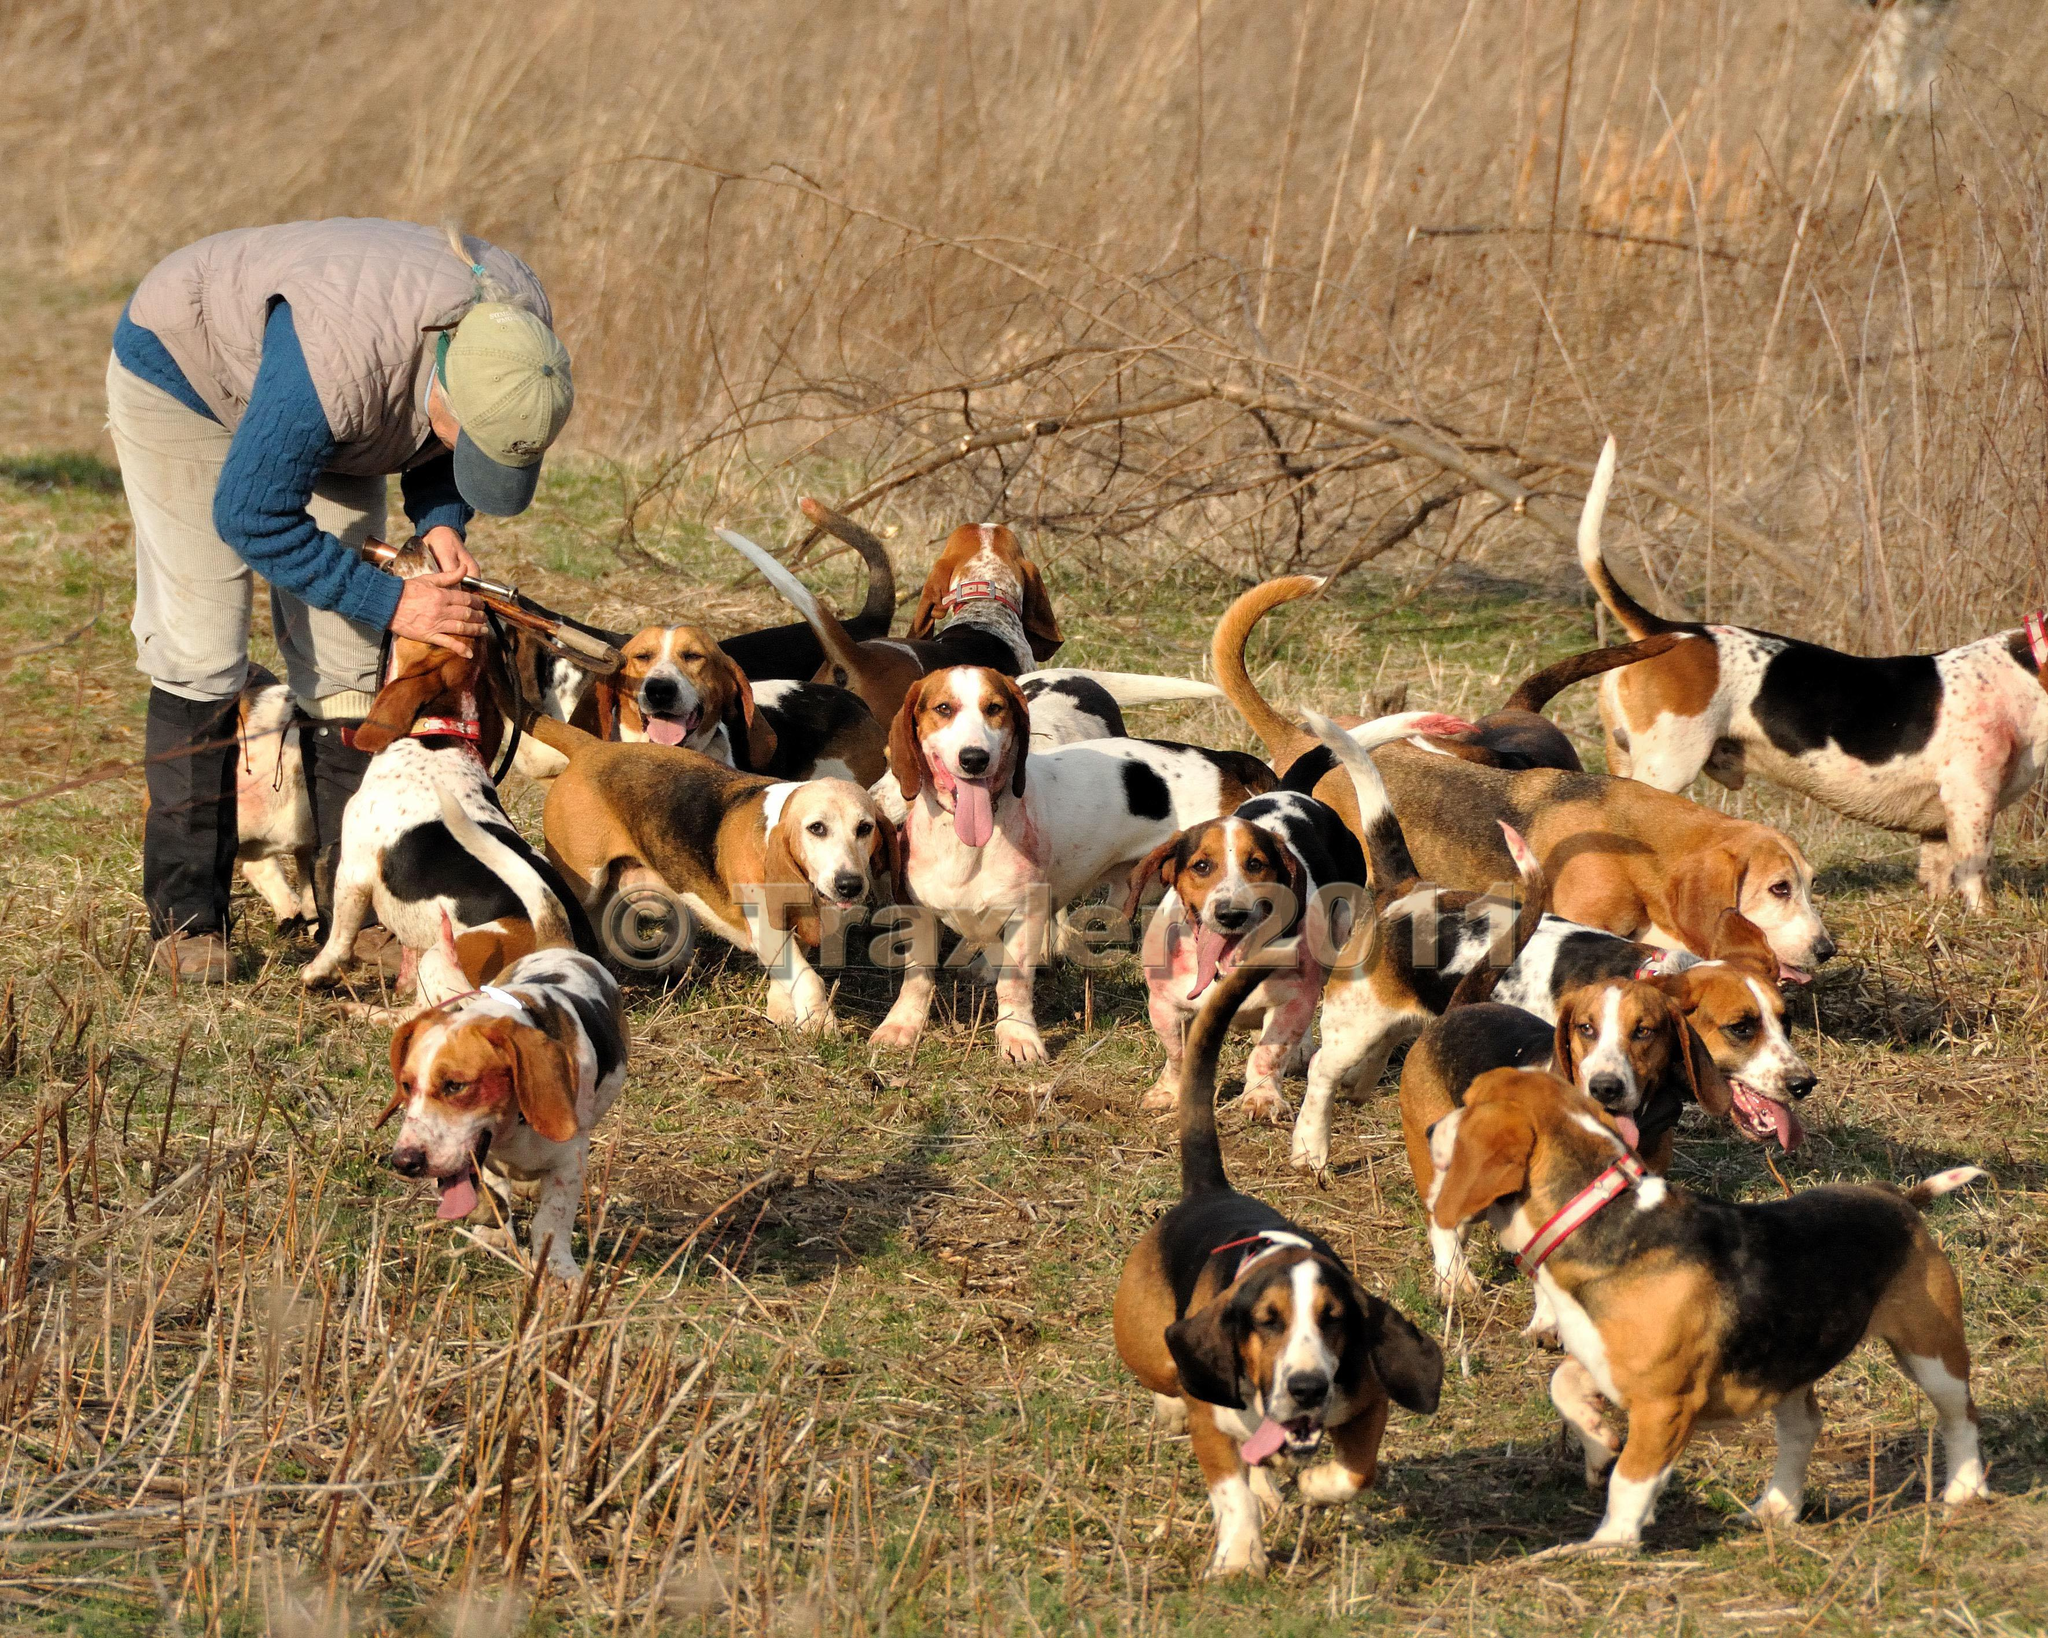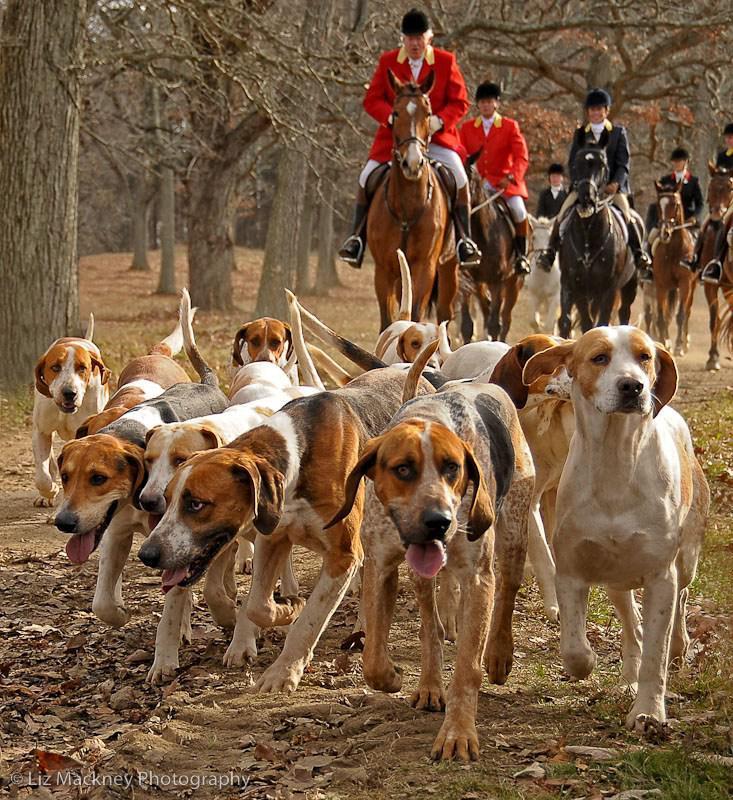The first image is the image on the left, the second image is the image on the right. Given the left and right images, does the statement "At least one of the images contains one or more rabbits." hold true? Answer yes or no. No. The first image is the image on the left, the second image is the image on the right. For the images displayed, is the sentence "At least one of the images shows only one dog." factually correct? Answer yes or no. No. The first image is the image on the left, the second image is the image on the right. Examine the images to the left and right. Is the description "There is a single person standing with a group of dogs in one of the images." accurate? Answer yes or no. Yes. The first image is the image on the left, the second image is the image on the right. Assess this claim about the two images: "1 dog has a tail that is sticking up.". Correct or not? Answer yes or no. No. 